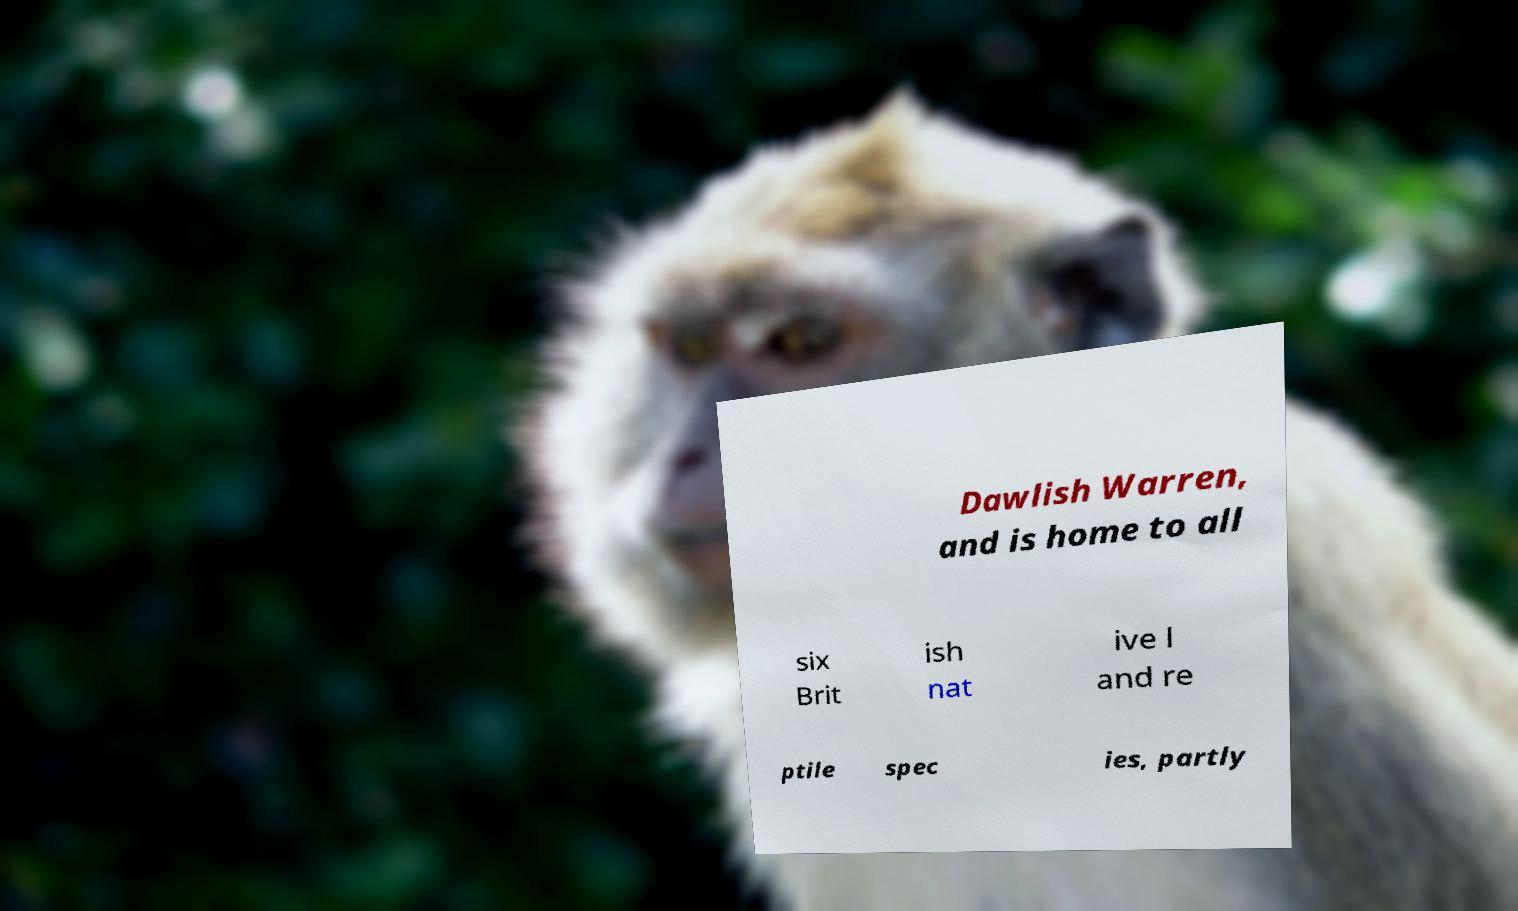For documentation purposes, I need the text within this image transcribed. Could you provide that? Dawlish Warren, and is home to all six Brit ish nat ive l and re ptile spec ies, partly 